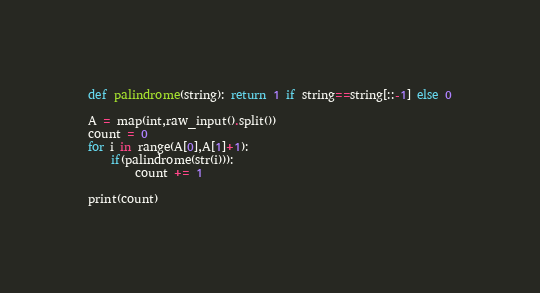Convert code to text. <code><loc_0><loc_0><loc_500><loc_500><_Python_>def palindrome(string): return 1 if string==string[::-1] else 0

A = map(int,raw_input().split())
count = 0
for i in range(A[0],A[1]+1):
    if(palindrome(str(i))):
        count += 1
    
print(count)

</code> 